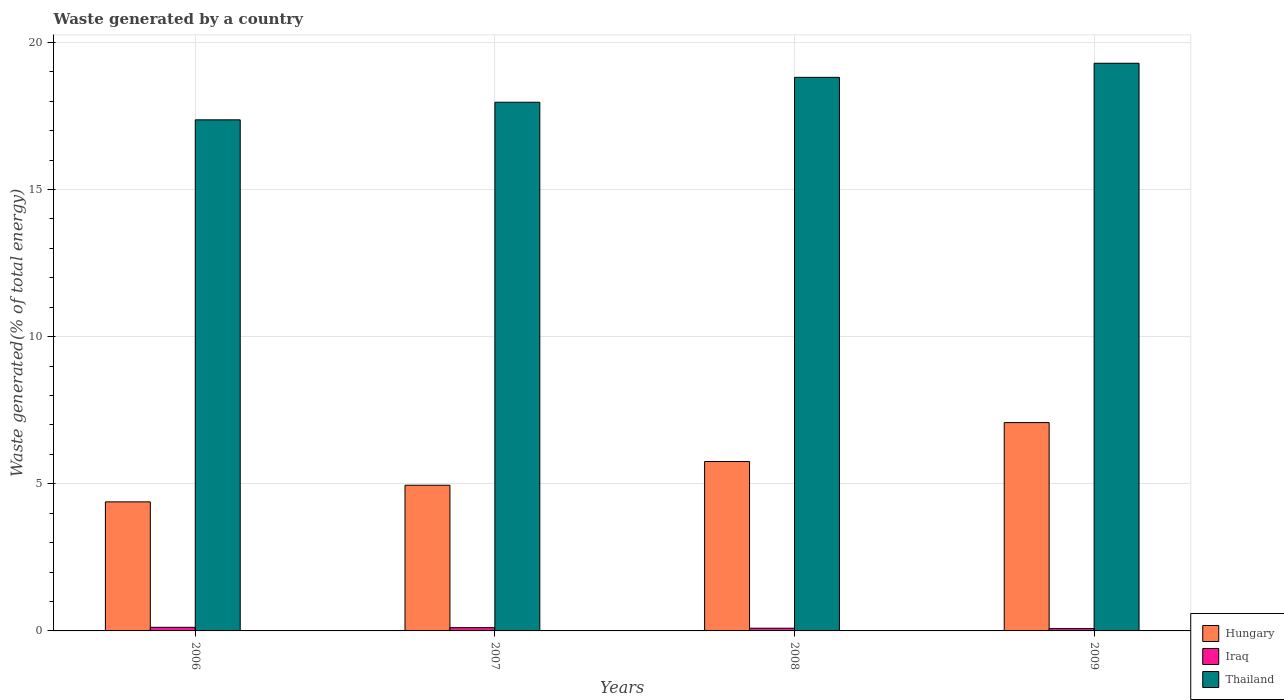How many different coloured bars are there?
Give a very brief answer. 3. Are the number of bars per tick equal to the number of legend labels?
Make the answer very short. Yes. How many bars are there on the 1st tick from the left?
Provide a short and direct response. 3. What is the label of the 4th group of bars from the left?
Your answer should be compact. 2009. In how many cases, is the number of bars for a given year not equal to the number of legend labels?
Keep it short and to the point. 0. What is the total waste generated in Thailand in 2006?
Your response must be concise. 17.37. Across all years, what is the maximum total waste generated in Thailand?
Your response must be concise. 19.29. Across all years, what is the minimum total waste generated in Hungary?
Your answer should be compact. 4.39. In which year was the total waste generated in Iraq minimum?
Offer a very short reply. 2009. What is the total total waste generated in Hungary in the graph?
Your answer should be very brief. 22.17. What is the difference between the total waste generated in Iraq in 2008 and that in 2009?
Offer a terse response. 0.01. What is the difference between the total waste generated in Hungary in 2007 and the total waste generated in Thailand in 2009?
Offer a terse response. -14.34. What is the average total waste generated in Hungary per year?
Make the answer very short. 5.54. In the year 2009, what is the difference between the total waste generated in Iraq and total waste generated in Hungary?
Your answer should be very brief. -7. What is the ratio of the total waste generated in Thailand in 2006 to that in 2007?
Your answer should be compact. 0.97. Is the total waste generated in Thailand in 2008 less than that in 2009?
Make the answer very short. Yes. Is the difference between the total waste generated in Iraq in 2008 and 2009 greater than the difference between the total waste generated in Hungary in 2008 and 2009?
Your response must be concise. Yes. What is the difference between the highest and the second highest total waste generated in Thailand?
Offer a terse response. 0.48. What is the difference between the highest and the lowest total waste generated in Thailand?
Give a very brief answer. 1.92. Is the sum of the total waste generated in Iraq in 2007 and 2009 greater than the maximum total waste generated in Thailand across all years?
Make the answer very short. No. What does the 1st bar from the left in 2006 represents?
Make the answer very short. Hungary. What does the 2nd bar from the right in 2008 represents?
Offer a terse response. Iraq. How many bars are there?
Provide a short and direct response. 12. How many years are there in the graph?
Make the answer very short. 4. What is the difference between two consecutive major ticks on the Y-axis?
Offer a very short reply. 5. Where does the legend appear in the graph?
Keep it short and to the point. Bottom right. How many legend labels are there?
Ensure brevity in your answer.  3. What is the title of the graph?
Offer a very short reply. Waste generated by a country. Does "Middle East & North Africa (all income levels)" appear as one of the legend labels in the graph?
Provide a succinct answer. No. What is the label or title of the X-axis?
Provide a short and direct response. Years. What is the label or title of the Y-axis?
Give a very brief answer. Waste generated(% of total energy). What is the Waste generated(% of total energy) of Hungary in 2006?
Provide a short and direct response. 4.39. What is the Waste generated(% of total energy) of Iraq in 2006?
Offer a terse response. 0.12. What is the Waste generated(% of total energy) of Thailand in 2006?
Your answer should be compact. 17.37. What is the Waste generated(% of total energy) in Hungary in 2007?
Make the answer very short. 4.95. What is the Waste generated(% of total energy) of Iraq in 2007?
Ensure brevity in your answer.  0.11. What is the Waste generated(% of total energy) of Thailand in 2007?
Offer a terse response. 17.97. What is the Waste generated(% of total energy) in Hungary in 2008?
Offer a terse response. 5.76. What is the Waste generated(% of total energy) in Iraq in 2008?
Your answer should be compact. 0.09. What is the Waste generated(% of total energy) in Thailand in 2008?
Keep it short and to the point. 18.81. What is the Waste generated(% of total energy) in Hungary in 2009?
Ensure brevity in your answer.  7.08. What is the Waste generated(% of total energy) in Iraq in 2009?
Provide a short and direct response. 0.08. What is the Waste generated(% of total energy) in Thailand in 2009?
Keep it short and to the point. 19.29. Across all years, what is the maximum Waste generated(% of total energy) of Hungary?
Your response must be concise. 7.08. Across all years, what is the maximum Waste generated(% of total energy) of Iraq?
Ensure brevity in your answer.  0.12. Across all years, what is the maximum Waste generated(% of total energy) in Thailand?
Offer a terse response. 19.29. Across all years, what is the minimum Waste generated(% of total energy) in Hungary?
Offer a very short reply. 4.39. Across all years, what is the minimum Waste generated(% of total energy) of Iraq?
Your response must be concise. 0.08. Across all years, what is the minimum Waste generated(% of total energy) in Thailand?
Offer a very short reply. 17.37. What is the total Waste generated(% of total energy) in Hungary in the graph?
Keep it short and to the point. 22.17. What is the total Waste generated(% of total energy) of Iraq in the graph?
Ensure brevity in your answer.  0.4. What is the total Waste generated(% of total energy) in Thailand in the graph?
Provide a short and direct response. 73.44. What is the difference between the Waste generated(% of total energy) in Hungary in 2006 and that in 2007?
Provide a short and direct response. -0.57. What is the difference between the Waste generated(% of total energy) in Iraq in 2006 and that in 2007?
Make the answer very short. 0.01. What is the difference between the Waste generated(% of total energy) in Thailand in 2006 and that in 2007?
Your answer should be compact. -0.6. What is the difference between the Waste generated(% of total energy) of Hungary in 2006 and that in 2008?
Provide a short and direct response. -1.37. What is the difference between the Waste generated(% of total energy) in Thailand in 2006 and that in 2008?
Your answer should be compact. -1.44. What is the difference between the Waste generated(% of total energy) in Hungary in 2006 and that in 2009?
Make the answer very short. -2.69. What is the difference between the Waste generated(% of total energy) of Iraq in 2006 and that in 2009?
Make the answer very short. 0.04. What is the difference between the Waste generated(% of total energy) in Thailand in 2006 and that in 2009?
Your answer should be compact. -1.92. What is the difference between the Waste generated(% of total energy) in Hungary in 2007 and that in 2008?
Offer a terse response. -0.81. What is the difference between the Waste generated(% of total energy) in Iraq in 2007 and that in 2008?
Offer a terse response. 0.02. What is the difference between the Waste generated(% of total energy) in Thailand in 2007 and that in 2008?
Give a very brief answer. -0.85. What is the difference between the Waste generated(% of total energy) of Hungary in 2007 and that in 2009?
Offer a very short reply. -2.13. What is the difference between the Waste generated(% of total energy) in Iraq in 2007 and that in 2009?
Offer a terse response. 0.03. What is the difference between the Waste generated(% of total energy) of Thailand in 2007 and that in 2009?
Your answer should be compact. -1.33. What is the difference between the Waste generated(% of total energy) in Hungary in 2008 and that in 2009?
Keep it short and to the point. -1.32. What is the difference between the Waste generated(% of total energy) in Iraq in 2008 and that in 2009?
Your answer should be compact. 0.01. What is the difference between the Waste generated(% of total energy) in Thailand in 2008 and that in 2009?
Provide a short and direct response. -0.48. What is the difference between the Waste generated(% of total energy) in Hungary in 2006 and the Waste generated(% of total energy) in Iraq in 2007?
Ensure brevity in your answer.  4.27. What is the difference between the Waste generated(% of total energy) of Hungary in 2006 and the Waste generated(% of total energy) of Thailand in 2007?
Your answer should be very brief. -13.58. What is the difference between the Waste generated(% of total energy) of Iraq in 2006 and the Waste generated(% of total energy) of Thailand in 2007?
Make the answer very short. -17.85. What is the difference between the Waste generated(% of total energy) of Hungary in 2006 and the Waste generated(% of total energy) of Iraq in 2008?
Your answer should be compact. 4.29. What is the difference between the Waste generated(% of total energy) in Hungary in 2006 and the Waste generated(% of total energy) in Thailand in 2008?
Offer a very short reply. -14.43. What is the difference between the Waste generated(% of total energy) of Iraq in 2006 and the Waste generated(% of total energy) of Thailand in 2008?
Make the answer very short. -18.69. What is the difference between the Waste generated(% of total energy) in Hungary in 2006 and the Waste generated(% of total energy) in Iraq in 2009?
Your answer should be compact. 4.31. What is the difference between the Waste generated(% of total energy) of Hungary in 2006 and the Waste generated(% of total energy) of Thailand in 2009?
Provide a succinct answer. -14.91. What is the difference between the Waste generated(% of total energy) of Iraq in 2006 and the Waste generated(% of total energy) of Thailand in 2009?
Your answer should be very brief. -19.17. What is the difference between the Waste generated(% of total energy) of Hungary in 2007 and the Waste generated(% of total energy) of Iraq in 2008?
Ensure brevity in your answer.  4.86. What is the difference between the Waste generated(% of total energy) in Hungary in 2007 and the Waste generated(% of total energy) in Thailand in 2008?
Make the answer very short. -13.86. What is the difference between the Waste generated(% of total energy) of Iraq in 2007 and the Waste generated(% of total energy) of Thailand in 2008?
Ensure brevity in your answer.  -18.7. What is the difference between the Waste generated(% of total energy) in Hungary in 2007 and the Waste generated(% of total energy) in Iraq in 2009?
Offer a very short reply. 4.87. What is the difference between the Waste generated(% of total energy) of Hungary in 2007 and the Waste generated(% of total energy) of Thailand in 2009?
Offer a terse response. -14.34. What is the difference between the Waste generated(% of total energy) in Iraq in 2007 and the Waste generated(% of total energy) in Thailand in 2009?
Offer a very short reply. -19.18. What is the difference between the Waste generated(% of total energy) in Hungary in 2008 and the Waste generated(% of total energy) in Iraq in 2009?
Provide a short and direct response. 5.68. What is the difference between the Waste generated(% of total energy) of Hungary in 2008 and the Waste generated(% of total energy) of Thailand in 2009?
Offer a very short reply. -13.54. What is the difference between the Waste generated(% of total energy) in Iraq in 2008 and the Waste generated(% of total energy) in Thailand in 2009?
Your response must be concise. -19.2. What is the average Waste generated(% of total energy) in Hungary per year?
Your answer should be very brief. 5.54. What is the average Waste generated(% of total energy) of Iraq per year?
Offer a very short reply. 0.1. What is the average Waste generated(% of total energy) in Thailand per year?
Your answer should be very brief. 18.36. In the year 2006, what is the difference between the Waste generated(% of total energy) in Hungary and Waste generated(% of total energy) in Iraq?
Keep it short and to the point. 4.26. In the year 2006, what is the difference between the Waste generated(% of total energy) of Hungary and Waste generated(% of total energy) of Thailand?
Your response must be concise. -12.98. In the year 2006, what is the difference between the Waste generated(% of total energy) in Iraq and Waste generated(% of total energy) in Thailand?
Offer a terse response. -17.25. In the year 2007, what is the difference between the Waste generated(% of total energy) of Hungary and Waste generated(% of total energy) of Iraq?
Offer a terse response. 4.84. In the year 2007, what is the difference between the Waste generated(% of total energy) in Hungary and Waste generated(% of total energy) in Thailand?
Offer a terse response. -13.02. In the year 2007, what is the difference between the Waste generated(% of total energy) of Iraq and Waste generated(% of total energy) of Thailand?
Your answer should be very brief. -17.86. In the year 2008, what is the difference between the Waste generated(% of total energy) in Hungary and Waste generated(% of total energy) in Iraq?
Provide a short and direct response. 5.66. In the year 2008, what is the difference between the Waste generated(% of total energy) in Hungary and Waste generated(% of total energy) in Thailand?
Keep it short and to the point. -13.06. In the year 2008, what is the difference between the Waste generated(% of total energy) in Iraq and Waste generated(% of total energy) in Thailand?
Offer a very short reply. -18.72. In the year 2009, what is the difference between the Waste generated(% of total energy) in Hungary and Waste generated(% of total energy) in Iraq?
Your response must be concise. 7. In the year 2009, what is the difference between the Waste generated(% of total energy) in Hungary and Waste generated(% of total energy) in Thailand?
Make the answer very short. -12.21. In the year 2009, what is the difference between the Waste generated(% of total energy) in Iraq and Waste generated(% of total energy) in Thailand?
Give a very brief answer. -19.21. What is the ratio of the Waste generated(% of total energy) in Hungary in 2006 to that in 2007?
Keep it short and to the point. 0.89. What is the ratio of the Waste generated(% of total energy) of Iraq in 2006 to that in 2007?
Your response must be concise. 1.1. What is the ratio of the Waste generated(% of total energy) of Thailand in 2006 to that in 2007?
Your answer should be very brief. 0.97. What is the ratio of the Waste generated(% of total energy) of Hungary in 2006 to that in 2008?
Offer a very short reply. 0.76. What is the ratio of the Waste generated(% of total energy) in Iraq in 2006 to that in 2008?
Provide a succinct answer. 1.33. What is the ratio of the Waste generated(% of total energy) in Thailand in 2006 to that in 2008?
Your answer should be compact. 0.92. What is the ratio of the Waste generated(% of total energy) in Hungary in 2006 to that in 2009?
Offer a very short reply. 0.62. What is the ratio of the Waste generated(% of total energy) in Iraq in 2006 to that in 2009?
Offer a very short reply. 1.54. What is the ratio of the Waste generated(% of total energy) of Thailand in 2006 to that in 2009?
Provide a succinct answer. 0.9. What is the ratio of the Waste generated(% of total energy) in Hungary in 2007 to that in 2008?
Provide a succinct answer. 0.86. What is the ratio of the Waste generated(% of total energy) in Iraq in 2007 to that in 2008?
Offer a very short reply. 1.2. What is the ratio of the Waste generated(% of total energy) of Thailand in 2007 to that in 2008?
Offer a terse response. 0.95. What is the ratio of the Waste generated(% of total energy) of Hungary in 2007 to that in 2009?
Give a very brief answer. 0.7. What is the ratio of the Waste generated(% of total energy) of Iraq in 2007 to that in 2009?
Provide a succinct answer. 1.4. What is the ratio of the Waste generated(% of total energy) in Thailand in 2007 to that in 2009?
Offer a very short reply. 0.93. What is the ratio of the Waste generated(% of total energy) of Hungary in 2008 to that in 2009?
Your answer should be very brief. 0.81. What is the ratio of the Waste generated(% of total energy) in Iraq in 2008 to that in 2009?
Make the answer very short. 1.16. What is the ratio of the Waste generated(% of total energy) in Thailand in 2008 to that in 2009?
Keep it short and to the point. 0.98. What is the difference between the highest and the second highest Waste generated(% of total energy) of Hungary?
Offer a very short reply. 1.32. What is the difference between the highest and the second highest Waste generated(% of total energy) in Iraq?
Make the answer very short. 0.01. What is the difference between the highest and the second highest Waste generated(% of total energy) in Thailand?
Provide a succinct answer. 0.48. What is the difference between the highest and the lowest Waste generated(% of total energy) in Hungary?
Provide a short and direct response. 2.69. What is the difference between the highest and the lowest Waste generated(% of total energy) of Iraq?
Provide a short and direct response. 0.04. What is the difference between the highest and the lowest Waste generated(% of total energy) of Thailand?
Give a very brief answer. 1.92. 